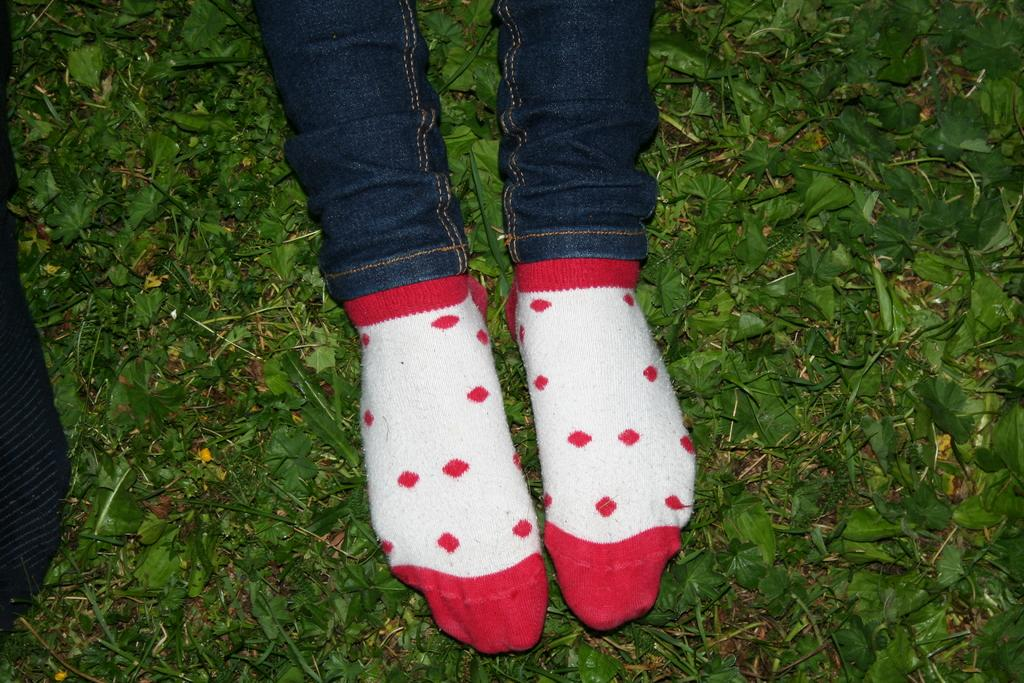What body part is visible in the image? There are person's legs visible in the image. What type of clothing is the person wearing on their legs? The person is wearing socks. What type of natural elements can be seen in the image? There are leaves in the image. What color is the black object in the image? The black object in the image is black. What word does the person say in the image? There is no indication of any spoken words in the image. Is there a dog present in the image? There is no dog present in the image. 